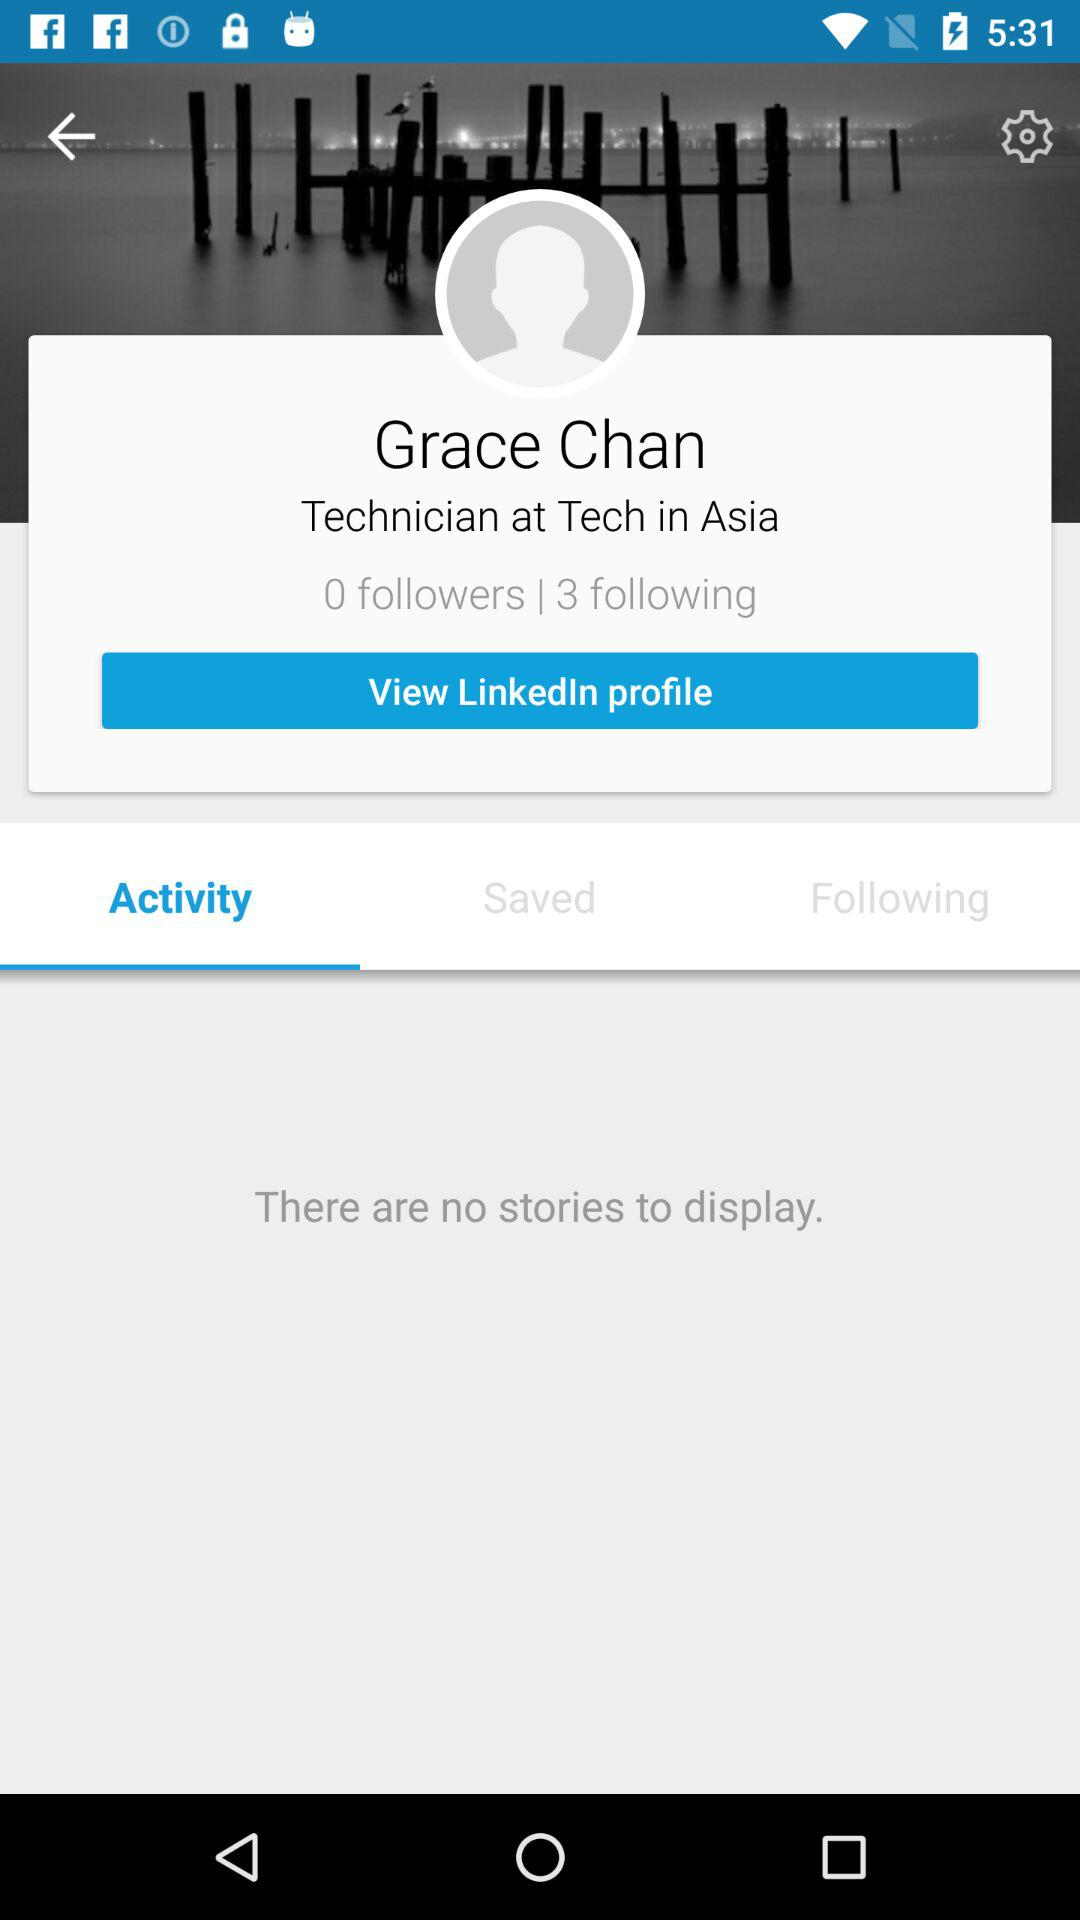How many followers does the user have? The user have 0 followers. 